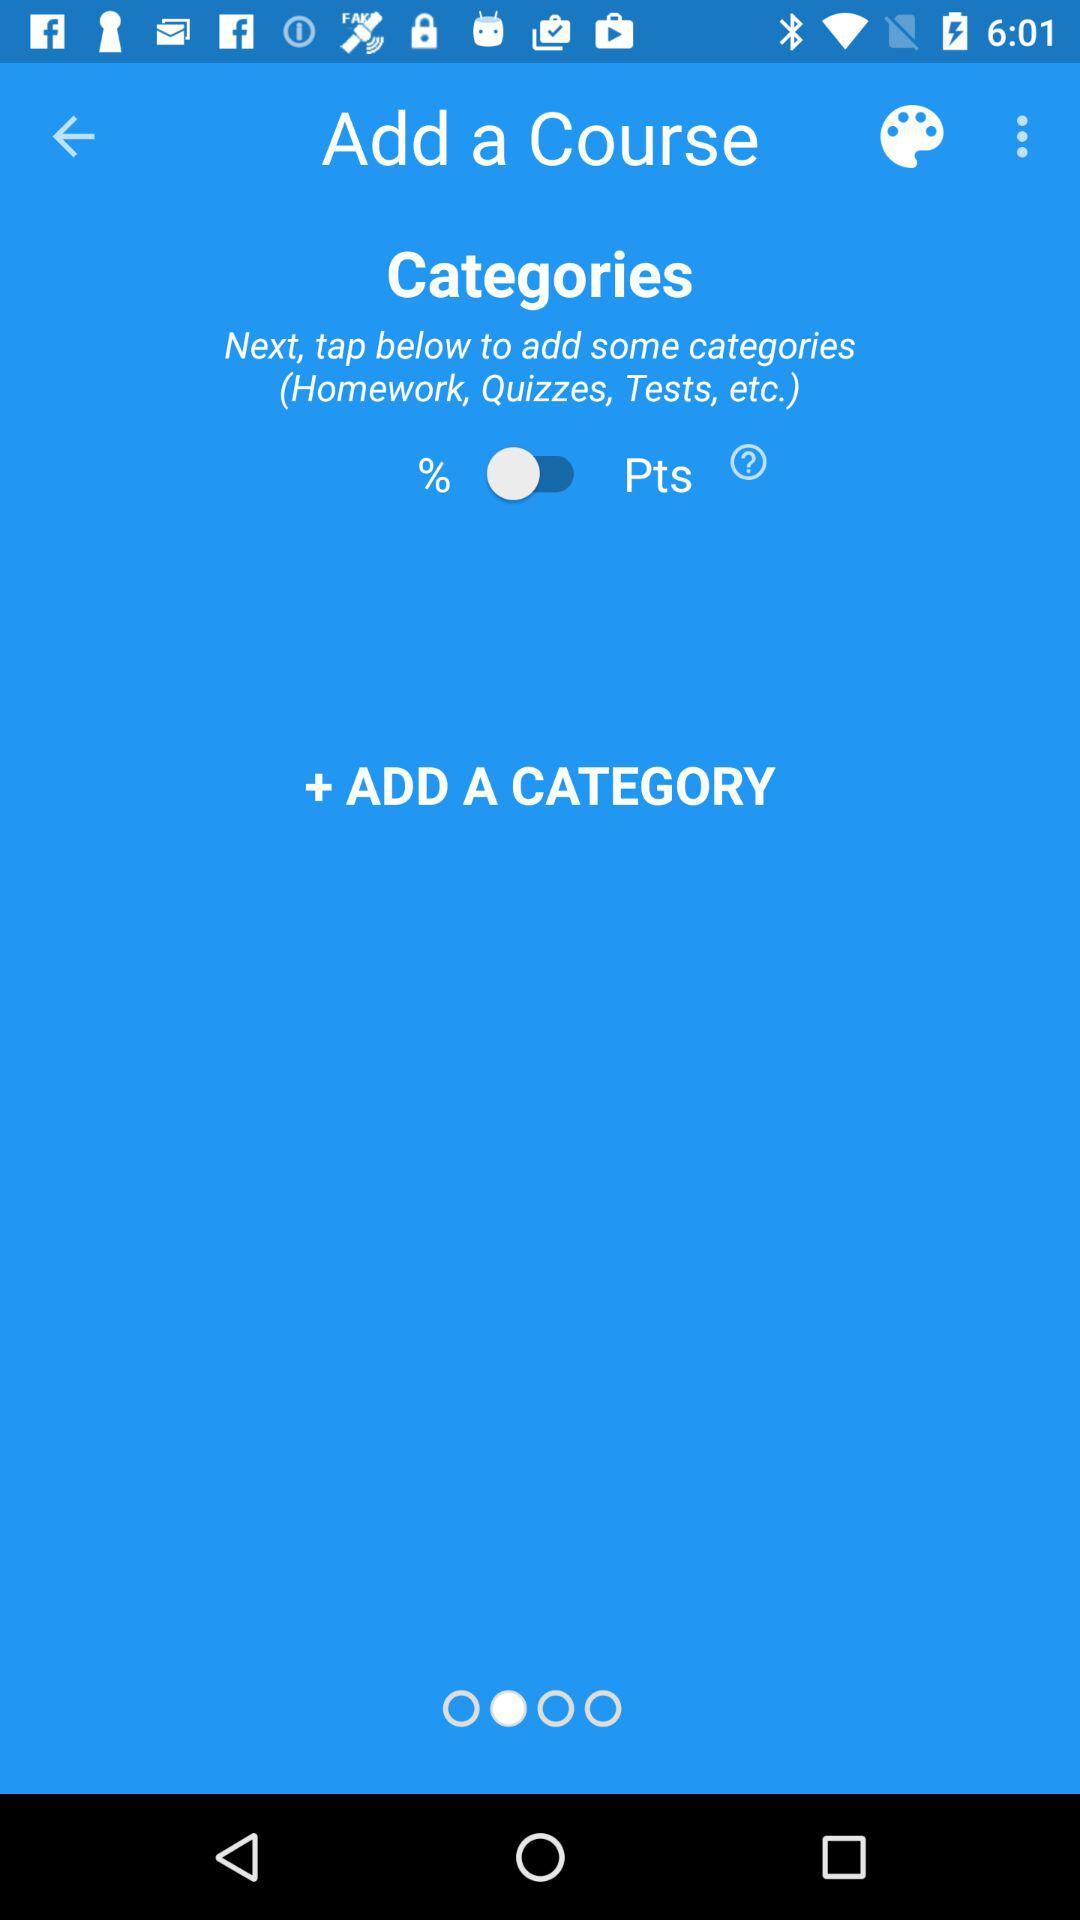Is "%" selected or not?
Answer the question using a single word or phrase. "%" is selected. 